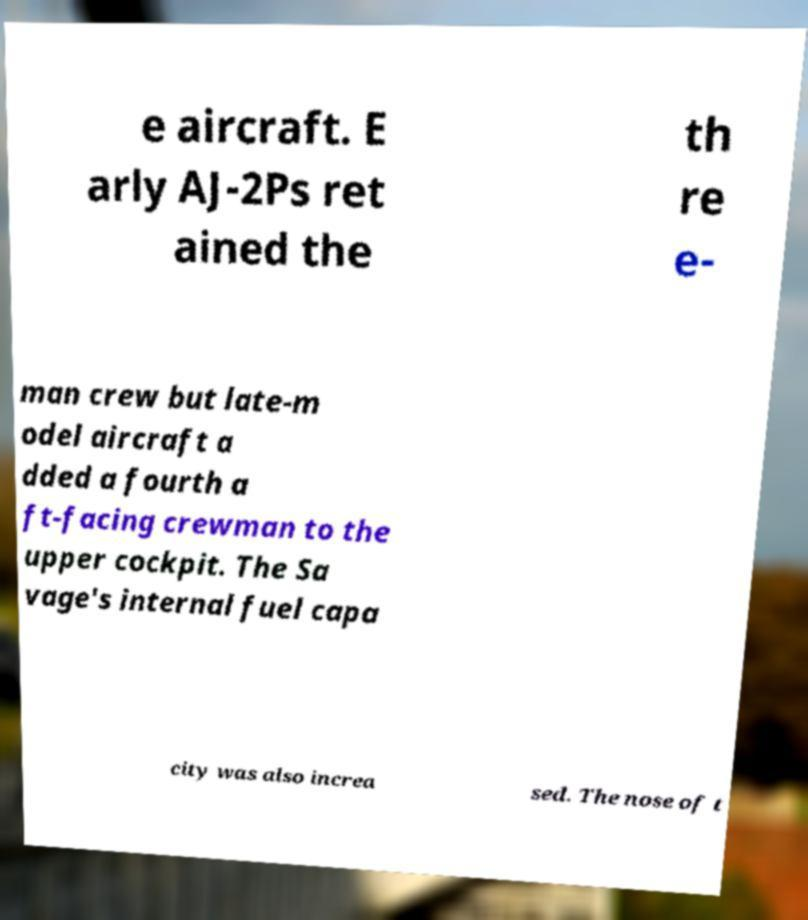There's text embedded in this image that I need extracted. Can you transcribe it verbatim? e aircraft. E arly AJ-2Ps ret ained the th re e- man crew but late-m odel aircraft a dded a fourth a ft-facing crewman to the upper cockpit. The Sa vage's internal fuel capa city was also increa sed. The nose of t 